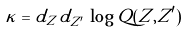Convert formula to latex. <formula><loc_0><loc_0><loc_500><loc_500>\kappa = d _ { Z } \, d _ { Z ^ { \prime } } \, \log Q ( Z , Z ^ { \prime } )</formula> 